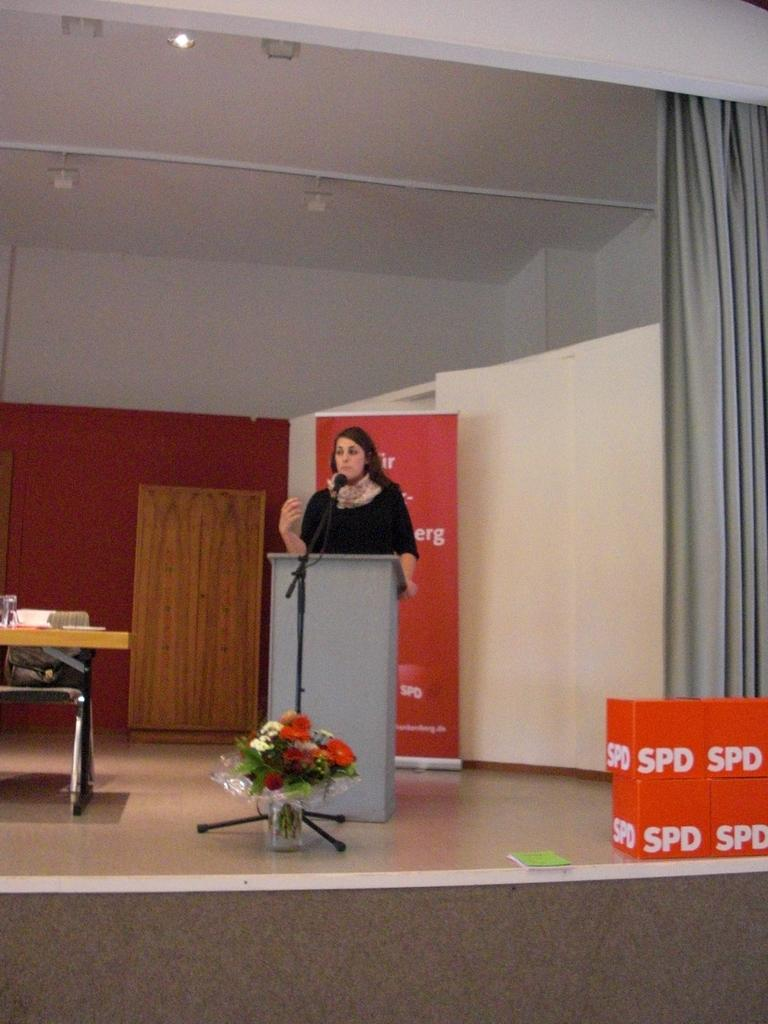Who is the main subject in the image? There is a woman in the image. What is the woman doing in the image? The woman is standing in front of a mic. What other objects can be seen in the image? There is a flower pot, a grey curtain, and a table in the image. What is on the table? There are items on the table. What type of straw can be seen on the street in the image? There is no straw or street present in the image. How does the friction between the woman and the mic affect the sound quality in the image? The facts provided do not give us any information about the sound quality or the friction between the woman and the mic. 